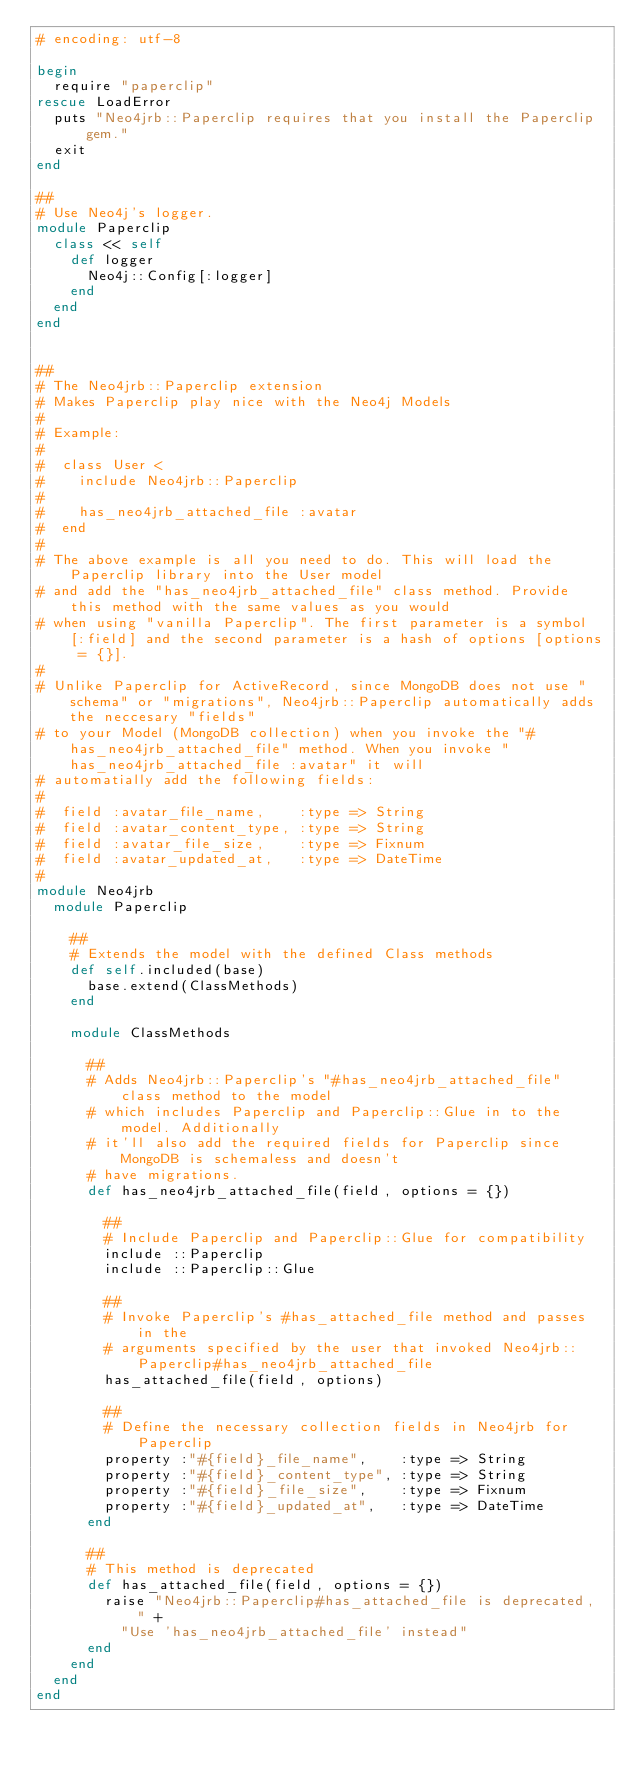<code> <loc_0><loc_0><loc_500><loc_500><_Ruby_># encoding: utf-8

begin
  require "paperclip"
rescue LoadError
  puts "Neo4jrb::Paperclip requires that you install the Paperclip gem."
  exit
end

##
# Use Neo4j's logger.
module Paperclip
  class << self
    def logger
      Neo4j::Config[:logger]
    end
  end
end


##
# The Neo4jrb::Paperclip extension
# Makes Paperclip play nice with the Neo4j Models
#
# Example:
#
#  class User < 
#    include Neo4jrb::Paperclip
#
#    has_neo4jrb_attached_file :avatar
#  end
#
# The above example is all you need to do. This will load the Paperclip library into the User model
# and add the "has_neo4jrb_attached_file" class method. Provide this method with the same values as you would
# when using "vanilla Paperclip". The first parameter is a symbol [:field] and the second parameter is a hash of options [options = {}].
#
# Unlike Paperclip for ActiveRecord, since MongoDB does not use "schema" or "migrations", Neo4jrb::Paperclip automatically adds the neccesary "fields"
# to your Model (MongoDB collection) when you invoke the "#has_neo4jrb_attached_file" method. When you invoke "has_neo4jrb_attached_file :avatar" it will
# automatially add the following fields:
#
#  field :avatar_file_name,    :type => String
#  field :avatar_content_type, :type => String
#  field :avatar_file_size,    :type => Fixnum
#  field :avatar_updated_at,   :type => DateTime
#
module Neo4jrb 
  module Paperclip

    ##
    # Extends the model with the defined Class methods
    def self.included(base)
      base.extend(ClassMethods)
    end

    module ClassMethods

      ##
      # Adds Neo4jrb::Paperclip's "#has_neo4jrb_attached_file" class method to the model
      # which includes Paperclip and Paperclip::Glue in to the model. Additionally
      # it'll also add the required fields for Paperclip since MongoDB is schemaless and doesn't
      # have migrations.
      def has_neo4jrb_attached_file(field, options = {})

        ##
        # Include Paperclip and Paperclip::Glue for compatibility
        include ::Paperclip
        include ::Paperclip::Glue

        ##
        # Invoke Paperclip's #has_attached_file method and passes in the
        # arguments specified by the user that invoked Neo4jrb::Paperclip#has_neo4jrb_attached_file
        has_attached_file(field, options)

        ##
        # Define the necessary collection fields in Neo4jrb for Paperclip
        property :"#{field}_file_name",    :type => String
        property :"#{field}_content_type", :type => String
        property :"#{field}_file_size",    :type => Fixnum 
        property :"#{field}_updated_at",   :type => DateTime
      end

      ##
      # This method is deprecated
      def has_attached_file(field, options = {})
        raise "Neo4jrb::Paperclip#has_attached_file is deprecated, " +
          "Use 'has_neo4jrb_attached_file' instead"
      end
    end
  end
end
</code> 